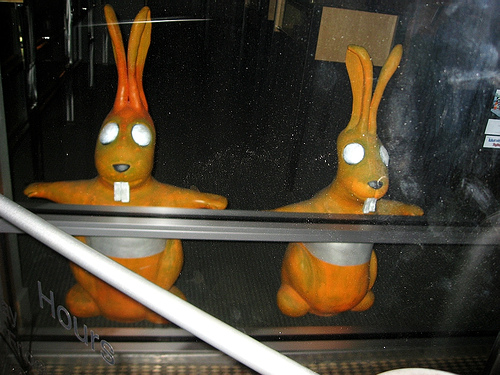<image>
Is the toy to the left of the toy? No. The toy is not to the left of the toy. From this viewpoint, they have a different horizontal relationship. Where is the toy in relation to the toy? Is it next to the toy? Yes. The toy is positioned adjacent to the toy, located nearby in the same general area. Where is the creepy rabbit in relation to the window? Is it in front of the window? No. The creepy rabbit is not in front of the window. The spatial positioning shows a different relationship between these objects. 